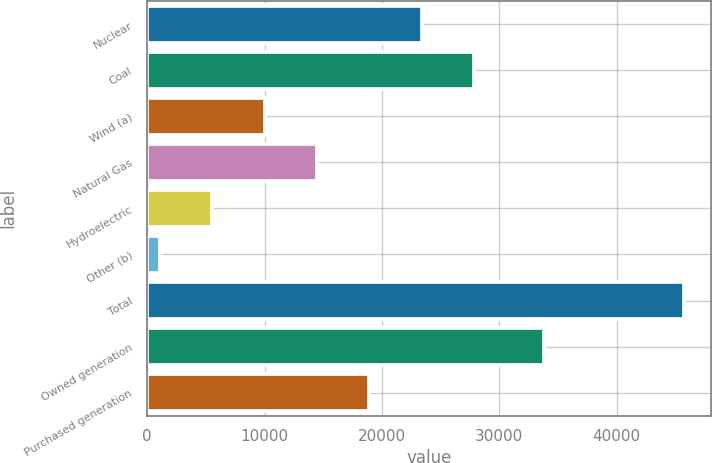Convert chart to OTSL. <chart><loc_0><loc_0><loc_500><loc_500><bar_chart><fcel>Nuclear<fcel>Coal<fcel>Wind (a)<fcel>Natural Gas<fcel>Hydroelectric<fcel>Other (b)<fcel>Total<fcel>Owned generation<fcel>Purchased generation<nl><fcel>23401<fcel>27864.6<fcel>10010.2<fcel>14473.8<fcel>5546.6<fcel>1083<fcel>45719<fcel>33818<fcel>18937.4<nl></chart> 